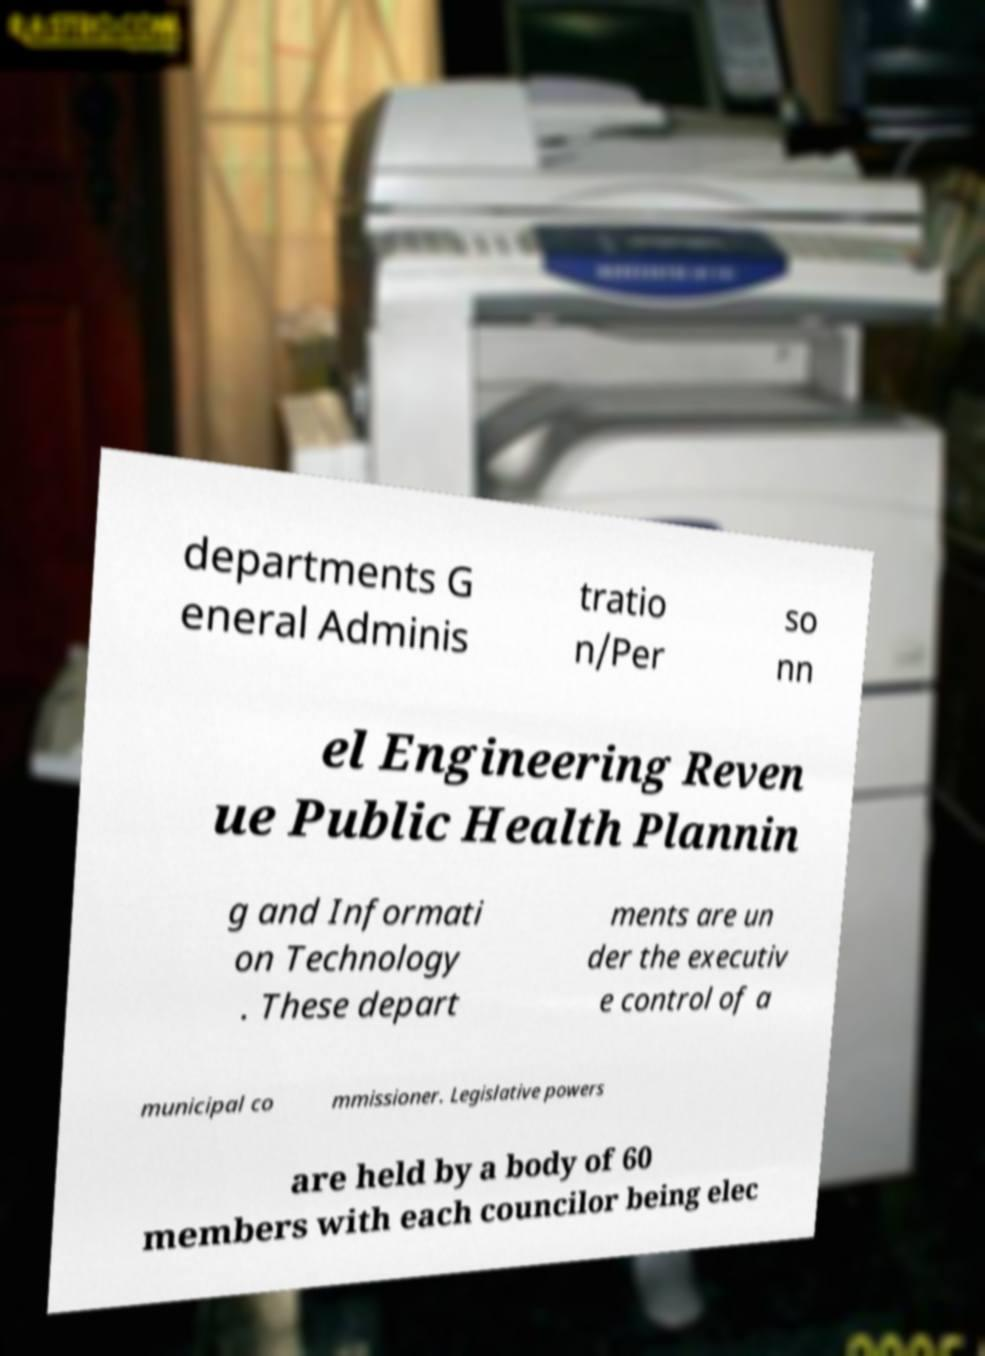Can you accurately transcribe the text from the provided image for me? departments G eneral Adminis tratio n/Per so nn el Engineering Reven ue Public Health Plannin g and Informati on Technology . These depart ments are un der the executiv e control of a municipal co mmissioner. Legislative powers are held by a body of 60 members with each councilor being elec 